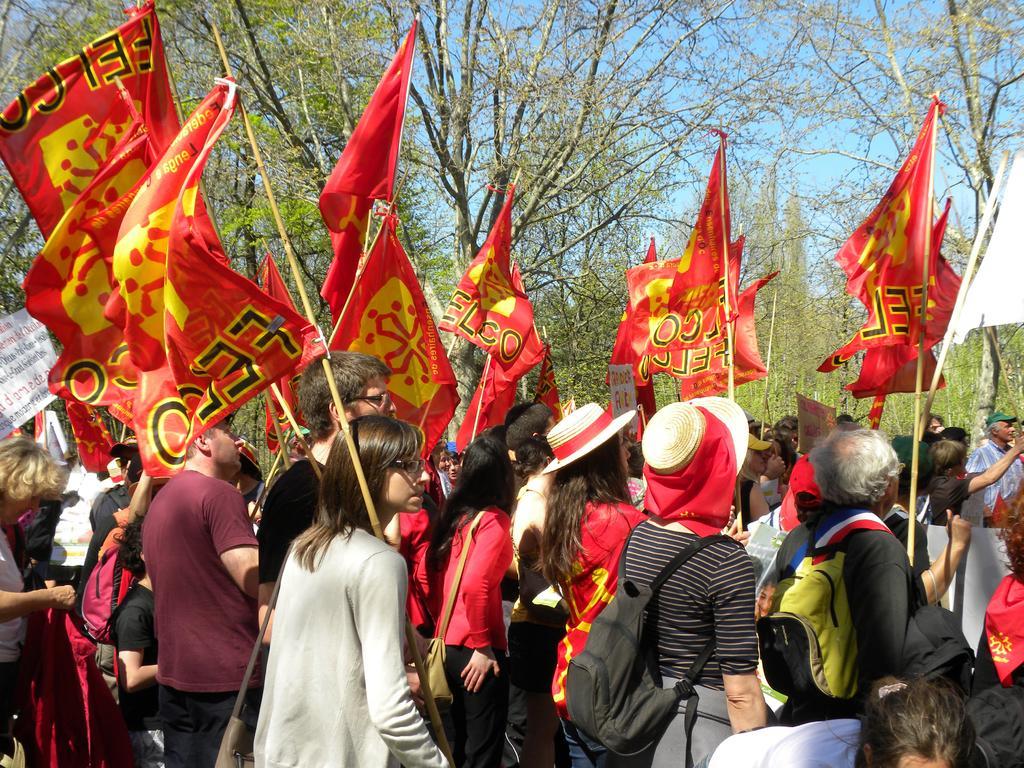How would you summarize this image in a sentence or two? In this picture we can see a group of people carrying bags, holding flags with their hands, some objects, trees and in the background we can see the sky. 